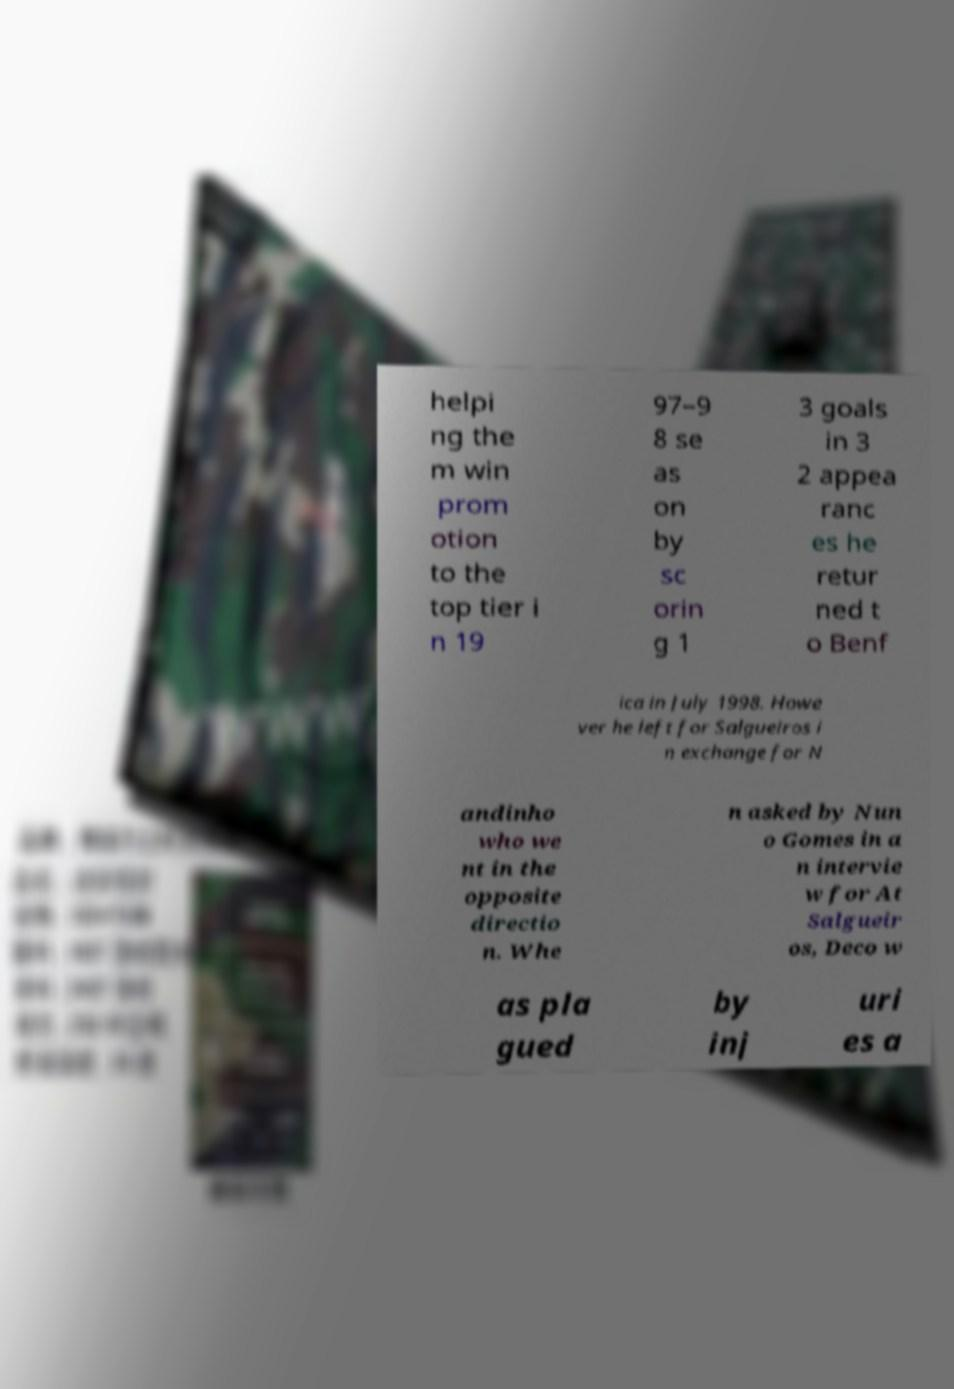Could you assist in decoding the text presented in this image and type it out clearly? helpi ng the m win prom otion to the top tier i n 19 97–9 8 se as on by sc orin g 1 3 goals in 3 2 appea ranc es he retur ned t o Benf ica in July 1998. Howe ver he left for Salgueiros i n exchange for N andinho who we nt in the opposite directio n. Whe n asked by Nun o Gomes in a n intervie w for At Salgueir os, Deco w as pla gued by inj uri es a 